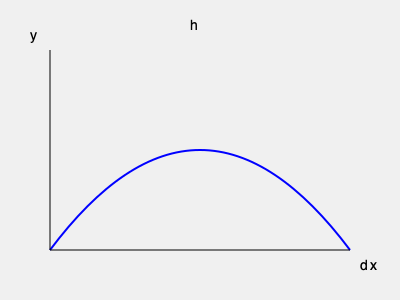A rocket's trajectory during launch can be modeled by a parabolic curve described by the equation $y = -\frac{4h}{d^2}x^2 + \frac{4h}{d}x$, where $h$ is the maximum height and $d$ is the total horizontal distance traveled. If the rocket reaches a maximum height of 120 km and travels a total horizontal distance of 300 km, what is the rocket's height when it has traveled 150 km horizontally? Let's approach this step-by-step:

1) We are given that $h = 120$ km and $d = 300$ km.

2) We need to find $y$ when $x = 150$ km (half of the total horizontal distance).

3) Let's substitute these values into the equation:
   $y = -\frac{4(120)}{300^2}x^2 + \frac{4(120)}{300}x$

4) Simplify:
   $y = -\frac{480}{90000}x^2 + \frac{480}{300}x$
   $y = -\frac{1}{187.5}x^2 + 1.6x$

5) Now, let's substitute $x = 150$ into this equation:
   $y = -\frac{1}{187.5}(150)^2 + 1.6(150)$

6) Calculate:
   $y = -\frac{22500}{187.5} + 240$
   $y = -120 + 240$
   $y = 120$

Therefore, when the rocket has traveled 150 km horizontally, its height is 120 km.
Answer: 120 km 